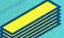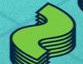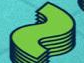Identify the words shown in these images in order, separated by a semicolon. -; ~; ~ 